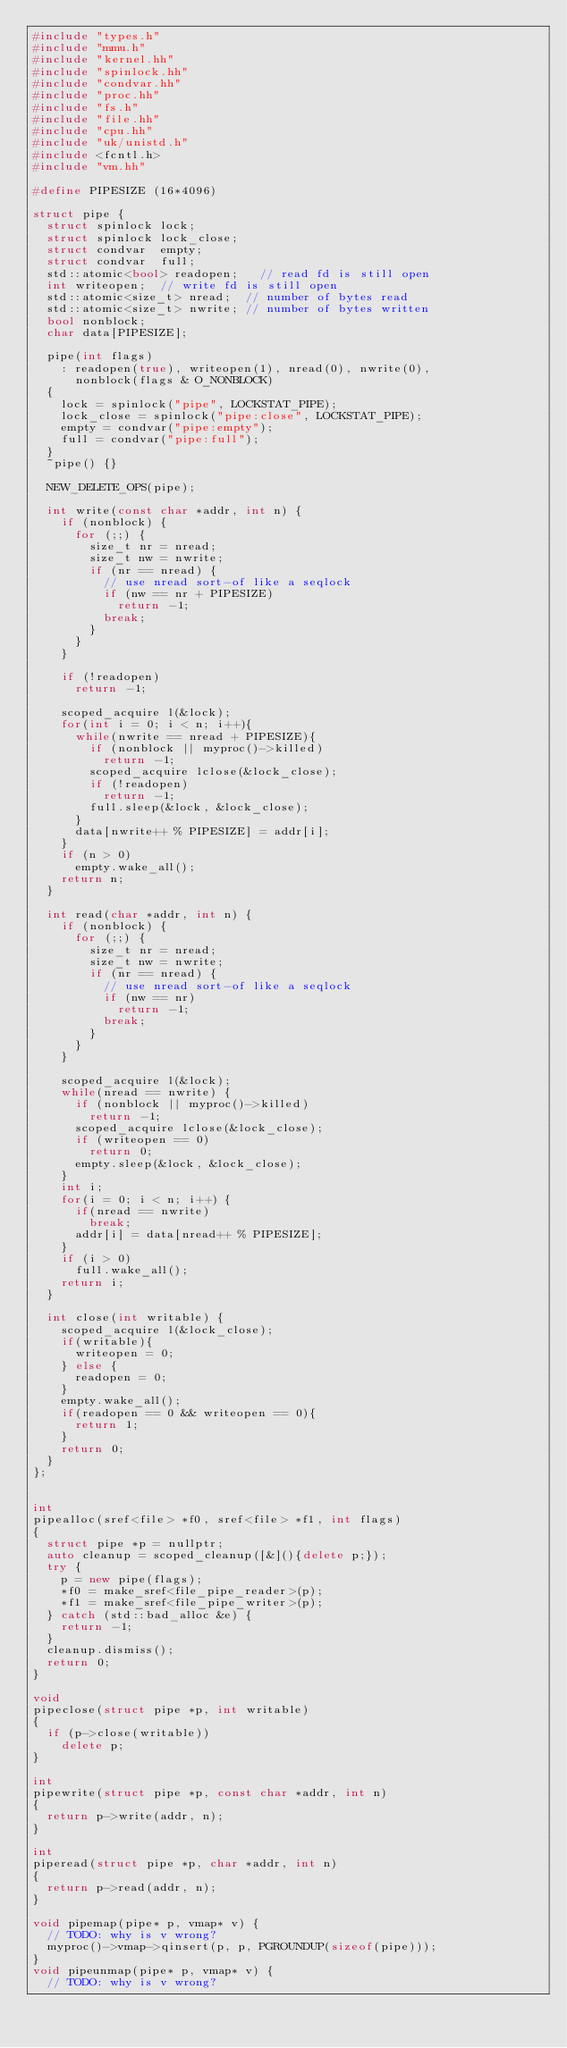Convert code to text. <code><loc_0><loc_0><loc_500><loc_500><_C++_>#include "types.h"
#include "mmu.h"
#include "kernel.hh"
#include "spinlock.hh"
#include "condvar.hh"
#include "proc.hh"
#include "fs.h"
#include "file.hh"
#include "cpu.hh"
#include "uk/unistd.h"
#include <fcntl.h>
#include "vm.hh"

#define PIPESIZE (16*4096)

struct pipe {
  struct spinlock lock;
  struct spinlock lock_close;
  struct condvar  empty;
  struct condvar  full;
  std::atomic<bool> readopen;   // read fd is still open
  int writeopen;  // write fd is still open
  std::atomic<size_t> nread;  // number of bytes read
  std::atomic<size_t> nwrite; // number of bytes written
  bool nonblock;
  char data[PIPESIZE];

  pipe(int flags)
    : readopen(true), writeopen(1), nread(0), nwrite(0),
      nonblock(flags & O_NONBLOCK)
  {
    lock = spinlock("pipe", LOCKSTAT_PIPE);
    lock_close = spinlock("pipe:close", LOCKSTAT_PIPE);
    empty = condvar("pipe:empty");
    full = condvar("pipe:full");
  }
  ~pipe() {}

  NEW_DELETE_OPS(pipe);

  int write(const char *addr, int n) {
    if (nonblock) {
      for (;;) {
        size_t nr = nread;
        size_t nw = nwrite;
        if (nr == nread) {
          // use nread sort-of like a seqlock
          if (nw == nr + PIPESIZE)
            return -1;
          break;
        }
      }
    }

    if (!readopen)
      return -1;

    scoped_acquire l(&lock);
    for(int i = 0; i < n; i++){
      while(nwrite == nread + PIPESIZE){
        if (nonblock || myproc()->killed)
          return -1;
        scoped_acquire lclose(&lock_close);
        if (!readopen)
          return -1;
        full.sleep(&lock, &lock_close);
      }
      data[nwrite++ % PIPESIZE] = addr[i];
    }
    if (n > 0)
      empty.wake_all();
    return n;
  }

  int read(char *addr, int n) {
    if (nonblock) {
      for (;;) {
        size_t nr = nread;
        size_t nw = nwrite;
        if (nr == nread) {
          // use nread sort-of like a seqlock
          if (nw == nr)
            return -1;
          break;
        }
      }
    }

    scoped_acquire l(&lock);
    while(nread == nwrite) {
      if (nonblock || myproc()->killed)
        return -1;
      scoped_acquire lclose(&lock_close);
      if (writeopen == 0)
        return 0;
      empty.sleep(&lock, &lock_close);
    }
    int i;
    for(i = 0; i < n; i++) {
      if(nread == nwrite)
        break;
      addr[i] = data[nread++ % PIPESIZE];
    }
    if (i > 0)
      full.wake_all();
    return i;
  }

  int close(int writable) {
    scoped_acquire l(&lock_close);
    if(writable){
      writeopen = 0;
    } else {
      readopen = 0;
    }
    empty.wake_all();
    if(readopen == 0 && writeopen == 0){
      return 1;
    }
    return 0;
  }
};


int
pipealloc(sref<file> *f0, sref<file> *f1, int flags)
{
  struct pipe *p = nullptr;
  auto cleanup = scoped_cleanup([&](){delete p;});
  try {
    p = new pipe(flags);
    *f0 = make_sref<file_pipe_reader>(p);
    *f1 = make_sref<file_pipe_writer>(p);
  } catch (std::bad_alloc &e) {
    return -1;
  }
  cleanup.dismiss();
  return 0;
}

void
pipeclose(struct pipe *p, int writable)
{
  if (p->close(writable))
    delete p;
}

int
pipewrite(struct pipe *p, const char *addr, int n)
{
  return p->write(addr, n);
}

int
piperead(struct pipe *p, char *addr, int n)
{
  return p->read(addr, n);
}

void pipemap(pipe* p, vmap* v) {
  // TODO: why is v wrong?
  myproc()->vmap->qinsert(p, p, PGROUNDUP(sizeof(pipe)));
}
void pipeunmap(pipe* p, vmap* v) {
  // TODO: why is v wrong?</code> 